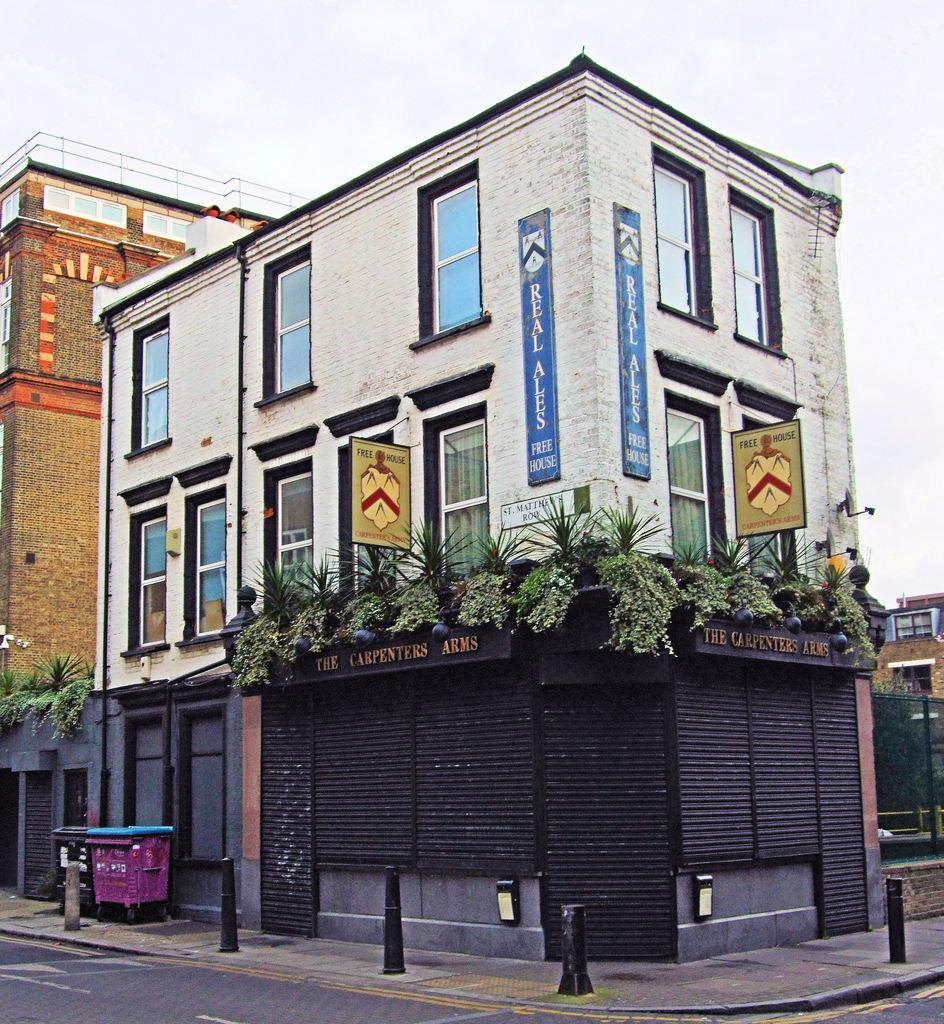In one or two sentences, can you explain what this image depicts? In this picture we can see a road. There are a few poles and dustbins on the path. We can see a few boards, plants and posters on a white building. There is a brown building on the left side. 